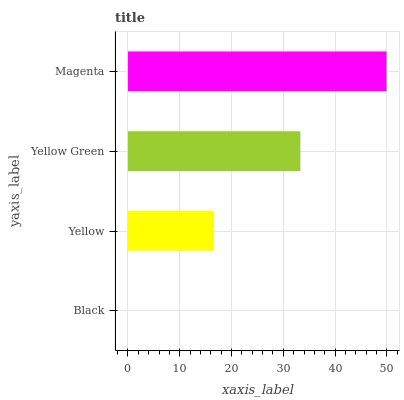Is Black the minimum?
Answer yes or no. Yes. Is Magenta the maximum?
Answer yes or no. Yes. Is Yellow the minimum?
Answer yes or no. No. Is Yellow the maximum?
Answer yes or no. No. Is Yellow greater than Black?
Answer yes or no. Yes. Is Black less than Yellow?
Answer yes or no. Yes. Is Black greater than Yellow?
Answer yes or no. No. Is Yellow less than Black?
Answer yes or no. No. Is Yellow Green the high median?
Answer yes or no. Yes. Is Yellow the low median?
Answer yes or no. Yes. Is Yellow the high median?
Answer yes or no. No. Is Magenta the low median?
Answer yes or no. No. 